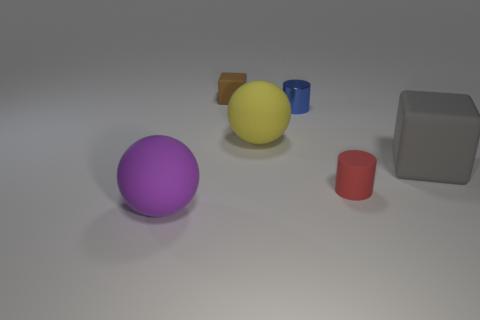Are there any other things that are made of the same material as the blue cylinder?
Make the answer very short. No. Is there a matte object of the same size as the red cylinder?
Give a very brief answer. Yes. Are there the same number of tiny rubber cubes that are in front of the large gray cube and large gray rubber things in front of the purple matte object?
Your answer should be compact. Yes. Are the object behind the blue shiny cylinder and the big sphere that is left of the brown matte block made of the same material?
Provide a short and direct response. Yes. What is the material of the small blue thing?
Your answer should be very brief. Metal. What number of other objects are the same color as the small rubber cylinder?
Offer a terse response. 0. How many red rubber things are there?
Offer a very short reply. 1. What material is the big ball right of the block that is behind the large yellow matte sphere made of?
Provide a short and direct response. Rubber. There is a yellow thing that is the same size as the purple rubber thing; what is it made of?
Keep it short and to the point. Rubber. Does the ball on the right side of the purple thing have the same size as the purple matte thing?
Give a very brief answer. Yes. 